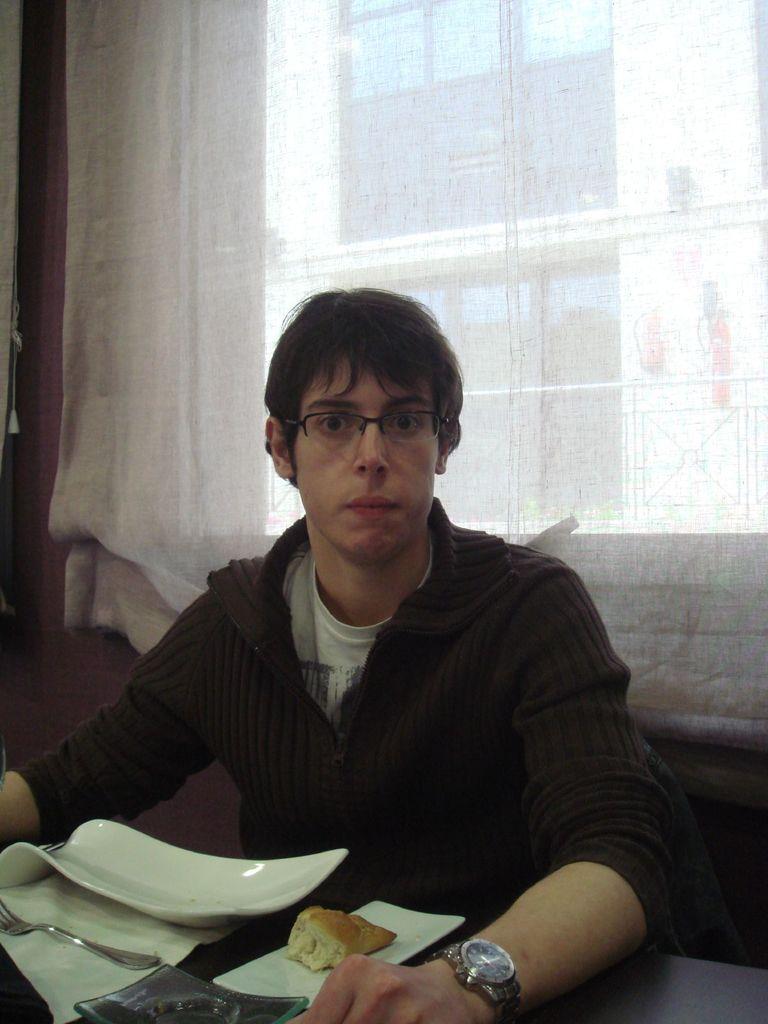Describe this image in one or two sentences. In this image we can see a person sitting in front of a table, on the table, we can see a spoon, napkin, plate, food item, behind the person we can see a window and a curtain, also we can see a building. 